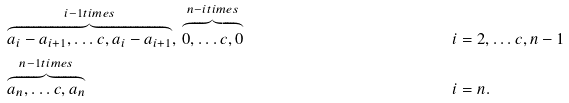Convert formula to latex. <formula><loc_0><loc_0><loc_500><loc_500>& \overbrace { a _ { i } - a _ { i + 1 } , \dots c , a _ { i } - a _ { i + 1 } } ^ { i - 1 t i m e s } , \, \overbrace { 0 , \dots c , 0 } ^ { n - i t i m e s } & i & = 2 , \dots c , n - 1 \\ & \overbrace { a _ { n } , \dots c , a _ { n } } ^ { n - 1 t i m e s } & i & = n .</formula> 